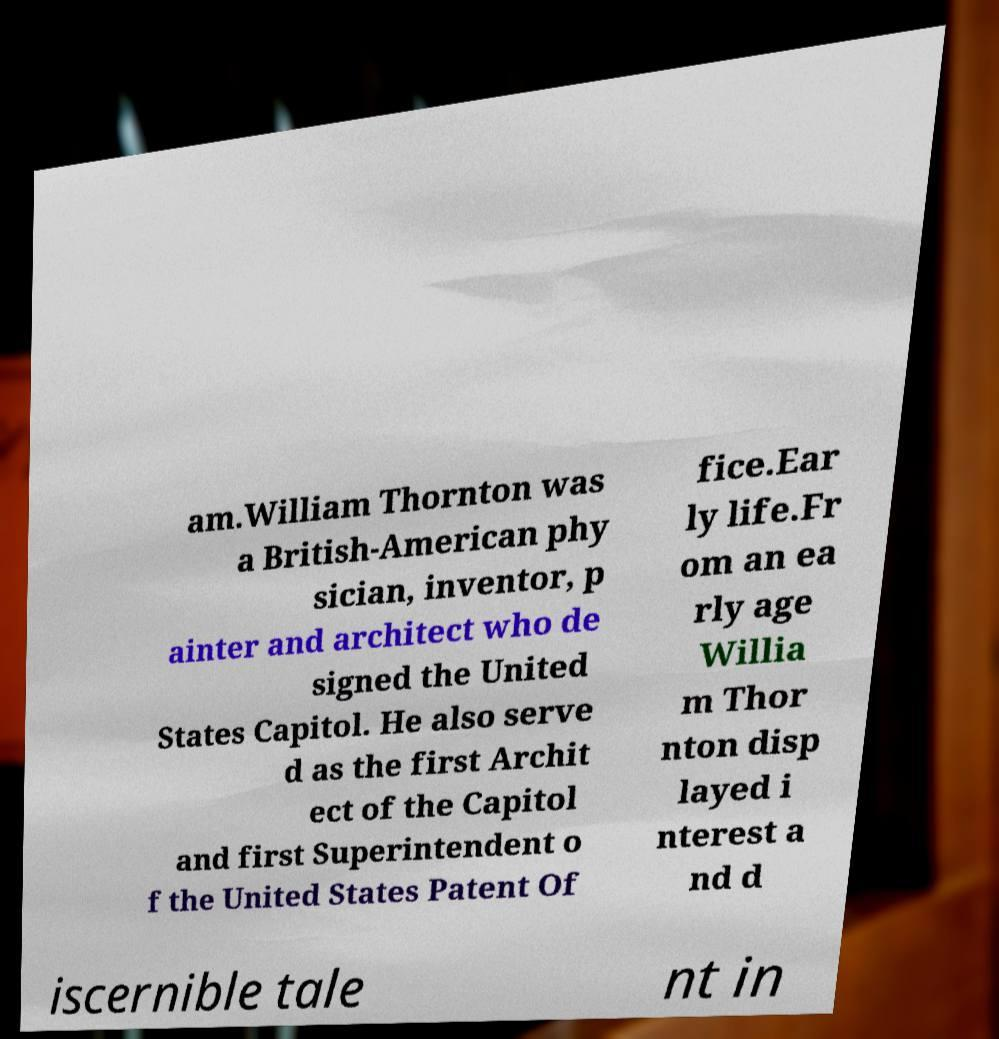Can you read and provide the text displayed in the image?This photo seems to have some interesting text. Can you extract and type it out for me? am.William Thornton was a British-American phy sician, inventor, p ainter and architect who de signed the United States Capitol. He also serve d as the first Archit ect of the Capitol and first Superintendent o f the United States Patent Of fice.Ear ly life.Fr om an ea rly age Willia m Thor nton disp layed i nterest a nd d iscernible tale nt in 